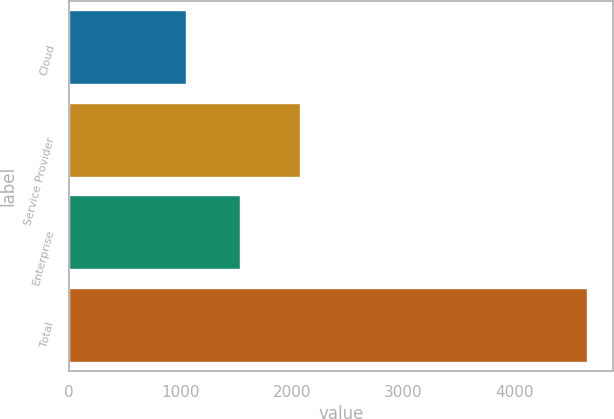Convert chart. <chart><loc_0><loc_0><loc_500><loc_500><bar_chart><fcel>Cloud<fcel>Service Provider<fcel>Enterprise<fcel>Total<nl><fcel>1049.9<fcel>2066.7<fcel>1530.9<fcel>4647.5<nl></chart> 